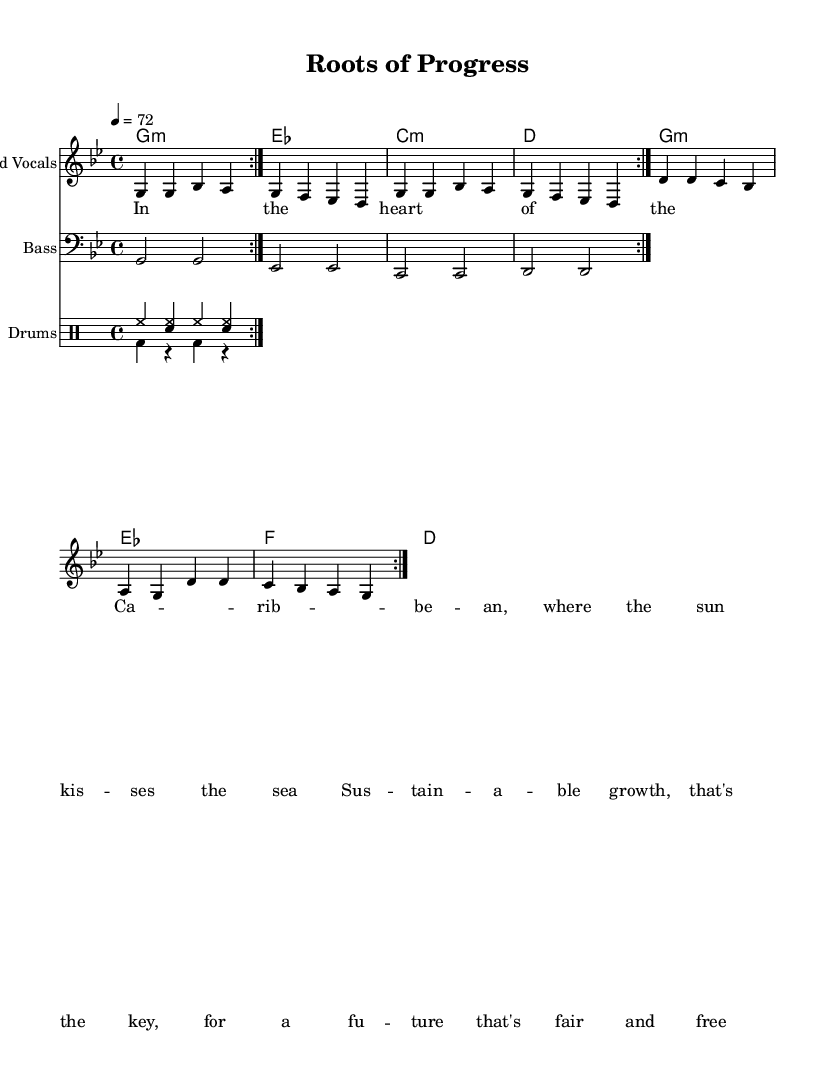What is the key signature of this music? The key signature is indicated at the beginning of the staff. It shows two flats, which corresponds to G minor.
Answer: G minor What is the time signature of the piece? The time signature is located at the beginning of the music. It shows a "4/4" indication, meaning there are four beats in a measure and the quarter note receives one beat.
Answer: 4/4 What is the tempo marking for the song? The tempo marking is found above the staff, indicating the speed of the piece. It states "4 = 72," meaning that there are 72 quarter note beats per minute.
Answer: 72 How many times is the melody repeated in the piece? In analyzing the melody section, there is a repeat indication "volta 2," which means that the melody is performed two times consecutively.
Answer: 2 What instrumental parts are included in the score? The score has various instrument parts, which include the lead vocals, bass, and drums. Each part is indicated separately in the score layout.
Answer: Lead Vocals, Bass, Drums How do the chord changes correlate with the lyrics? The chord changes occur at specific moments where the lyrics provide thematic content, such as sustainable growth; analyzing the chords in context with the lyrics reveals how they support the message of reform and development.
Answer: They support the message of reform and development 